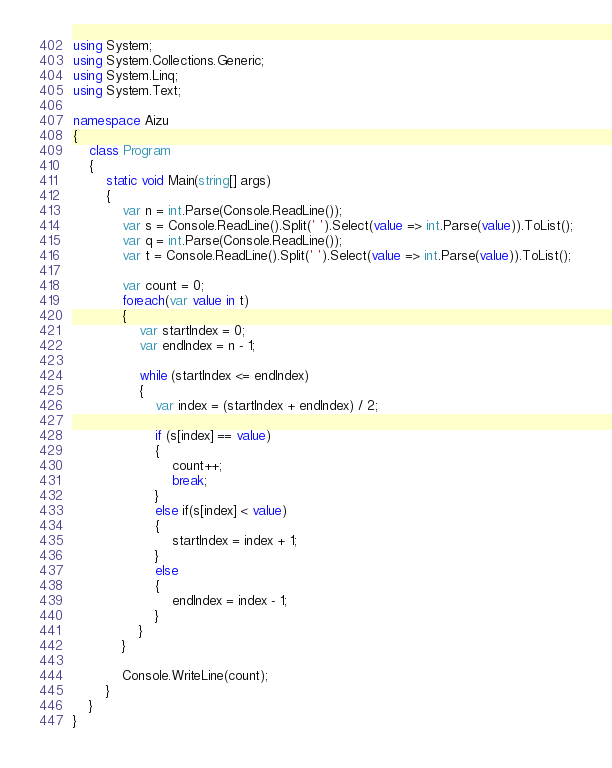<code> <loc_0><loc_0><loc_500><loc_500><_C#_>using System;
using System.Collections.Generic;
using System.Linq;
using System.Text;

namespace Aizu
{
	class Program
	{
		static void Main(string[] args)
		{
			var n = int.Parse(Console.ReadLine());
			var s = Console.ReadLine().Split(' ').Select(value => int.Parse(value)).ToList();
			var q = int.Parse(Console.ReadLine());
			var t = Console.ReadLine().Split(' ').Select(value => int.Parse(value)).ToList();

			var count = 0;
			foreach(var value in t)
			{
				var startIndex = 0;
				var endIndex = n - 1;

				while (startIndex <= endIndex)
				{
					var index = (startIndex + endIndex) / 2;

					if (s[index] == value)
					{
						count++;
						break;
					}
					else if(s[index] < value)
					{
						startIndex = index + 1;
					}
					else
					{
						endIndex = index - 1;
					}
				}
			}

			Console.WriteLine(count);
		}
	}
}

</code> 